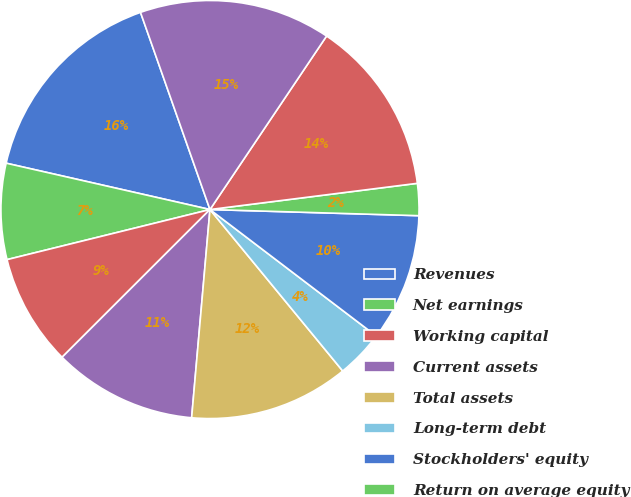Convert chart to OTSL. <chart><loc_0><loc_0><loc_500><loc_500><pie_chart><fcel>Revenues<fcel>Net earnings<fcel>Working capital<fcel>Current assets<fcel>Total assets<fcel>Long-term debt<fcel>Stockholders' equity<fcel>Return on average equity<fcel>Technical professional<fcel>Field services<nl><fcel>16.05%<fcel>7.41%<fcel>8.64%<fcel>11.11%<fcel>12.35%<fcel>3.7%<fcel>9.88%<fcel>2.47%<fcel>13.58%<fcel>14.81%<nl></chart> 